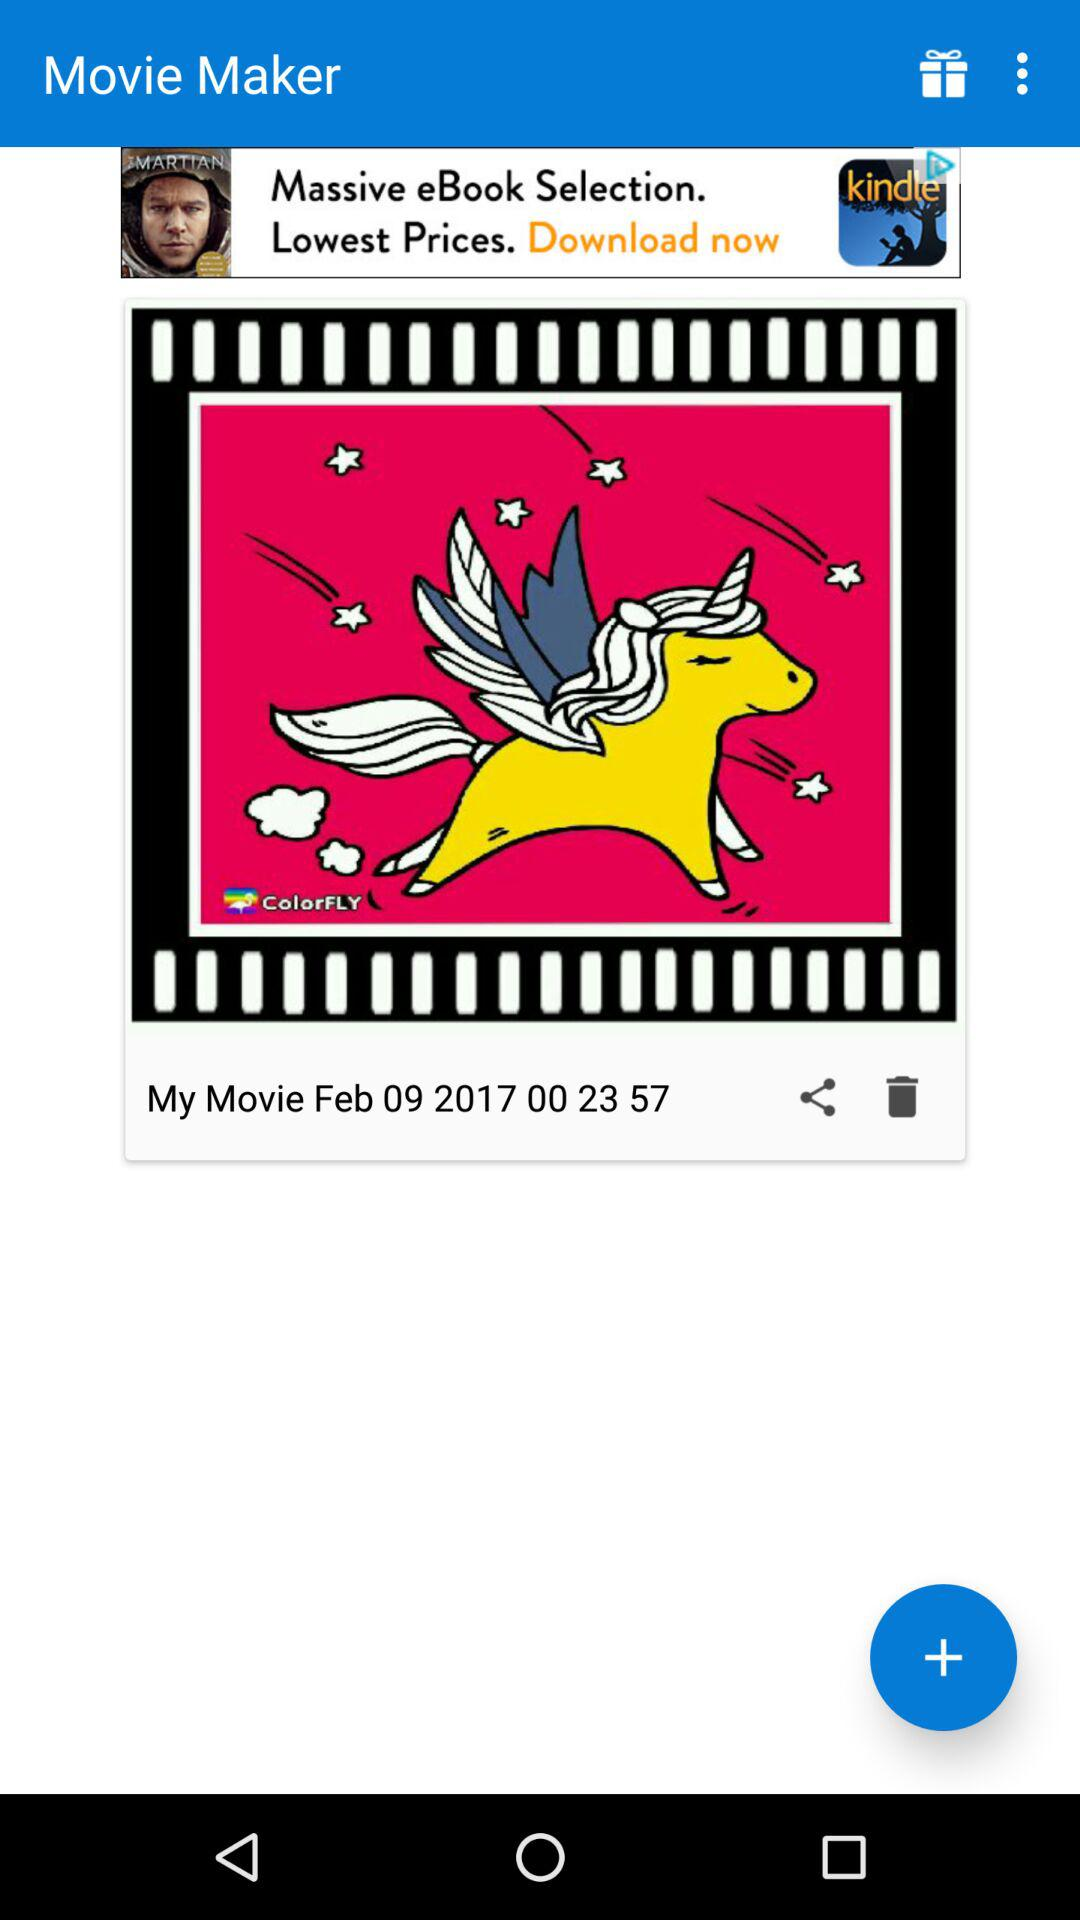What is the time? The time is 00:23:57. 